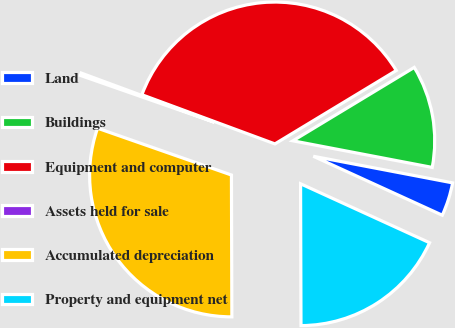<chart> <loc_0><loc_0><loc_500><loc_500><pie_chart><fcel>Land<fcel>Buildings<fcel>Equipment and computer<fcel>Assets held for sale<fcel>Accumulated depreciation<fcel>Property and equipment net<nl><fcel>3.82%<fcel>11.66%<fcel>35.71%<fcel>0.28%<fcel>30.4%<fcel>18.13%<nl></chart> 